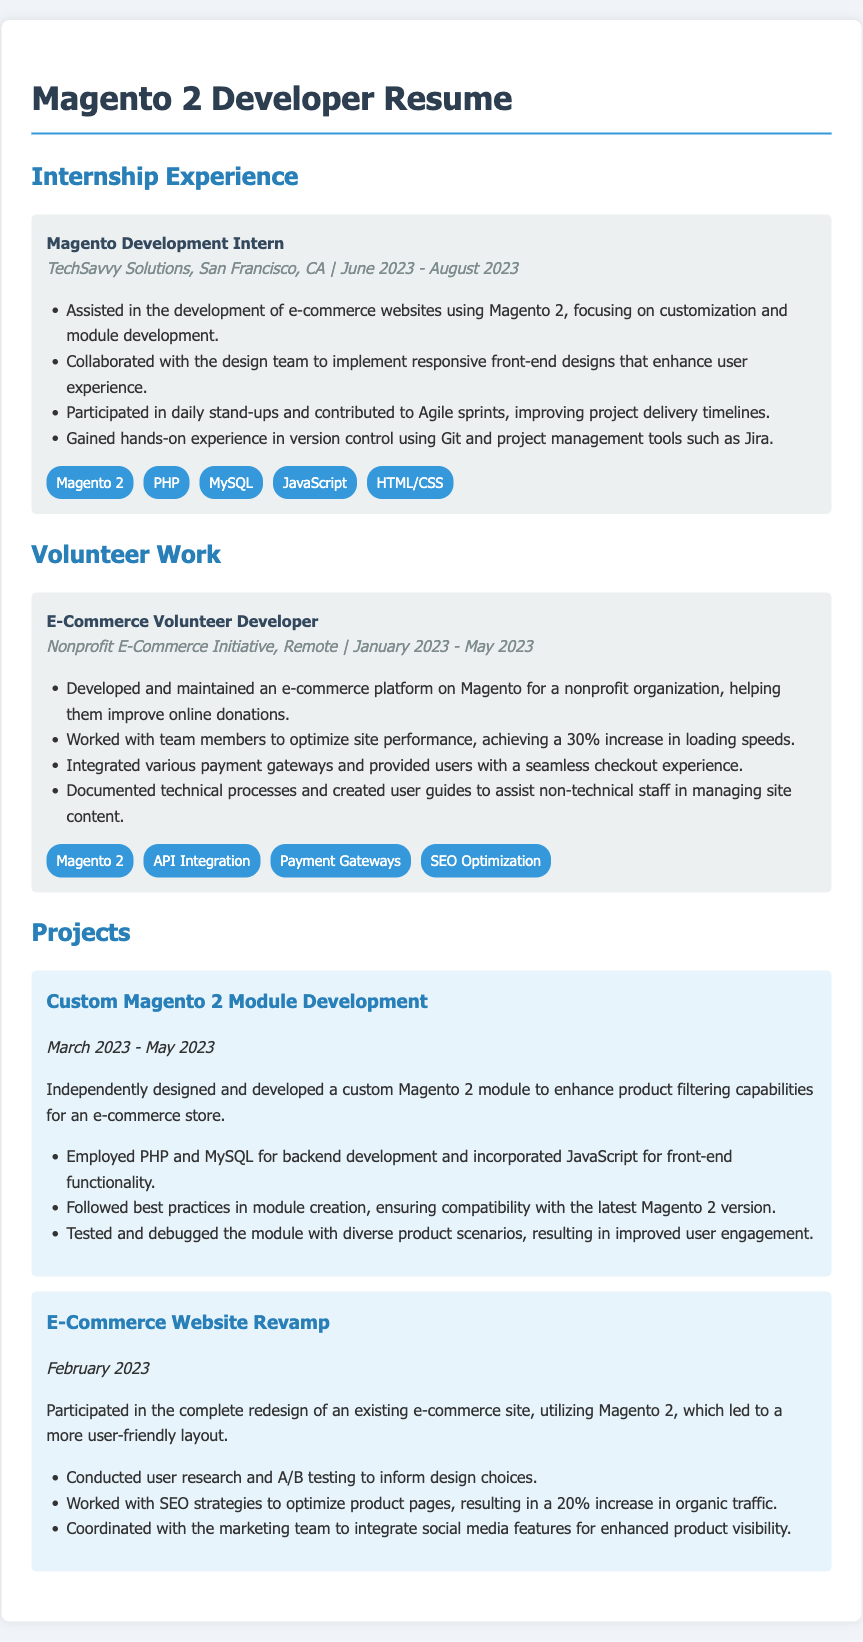What was the position held during the internship? The position held is stated in the "Internship Experience" section of the document.
Answer: Magento Development Intern What was the duration of the internship? The date range provided in the internship experience shows the period worked at the company.
Answer: June 2023 - August 2023 What organization was involved in the volunteer work? The organization's name is mentioned in the "Volunteer Work" section.
Answer: Nonprofit E-Commerce Initiative What was a key responsibility during the volunteer work? One of the main tasks outlined in the volunteer work item provides a specific responsibility.
Answer: Developed and maintained an e-commerce platform How much increase in loading speeds was achieved in the volunteer project? The document states a specific percentage increase related to site performance optimization.
Answer: 30% Which skills were highlighted during the internship? A list of skills is provided in the internship experience section detailing relevant competencies.
Answer: Magento 2, PHP, MySQL, JavaScript, HTML/CSS What type of module was developed in the project? The document states the specific type of development completed in the project section.
Answer: Custom Magento 2 module How many projects are listed in the document? The total number of projects mentioned can be counted from the "Projects" section.
Answer: 2 What was one of the outcomes of the e-commerce website revamp? The document indicates a particular result related to the redesign project.
Answer: 20% increase in organic traffic 